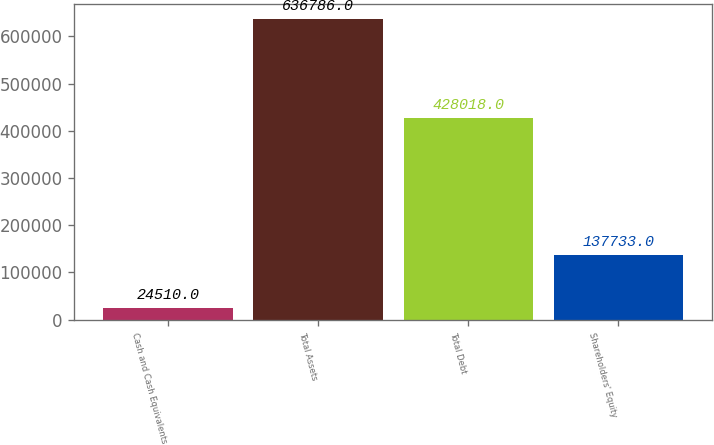<chart> <loc_0><loc_0><loc_500><loc_500><bar_chart><fcel>Cash and Cash Equivalents<fcel>Total Assets<fcel>Total Debt<fcel>Shareholders' Equity<nl><fcel>24510<fcel>636786<fcel>428018<fcel>137733<nl></chart> 